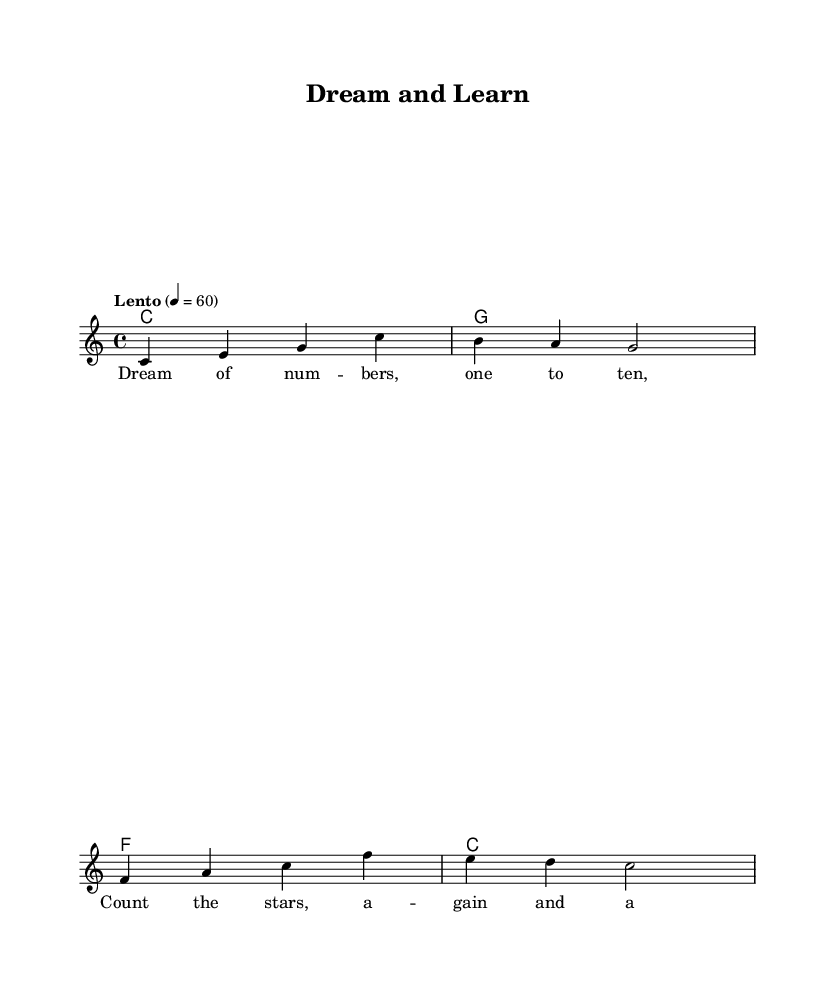What is the key signature of this music? The key signature is indicated at the beginning of the staff, showing no sharps or flats. This corresponds to C major.
Answer: C major What is the time signature of this piece? The time signature appears at the beginning of the music, displayed as a fraction. It shows 4 beats per measure, which is indicated by the notation "4/4".
Answer: 4/4 What is the tempo marking for this piece? The tempo marking instructs the speed of the piece and is found above the staff. It reads "Lento" and indicates a slow pace, at 60 beats per minute.
Answer: Lento How many measures are in the melody? By counting the vertical lines, known as bar lines, that segment the melody into parts, we find that there are four measures in total.
Answer: 4 What educational theme do the lyrics emphasize? The lyrics mention counting numbers and stars, indicating a focus on basic mathematics and observation skills for young children, thus fostering an educational theme.
Answer: Numbers What is the first note of the melody? The first note of the melody is shown on the staff and is the note "C", positioned at the bottom of the clef.
Answer: C What type of chords are used in the harmonies? The harmonies are presented in a chord progression format, where basic triads are used (C major, G major, F major, C major), highlighting common root chords.
Answer: Triads 